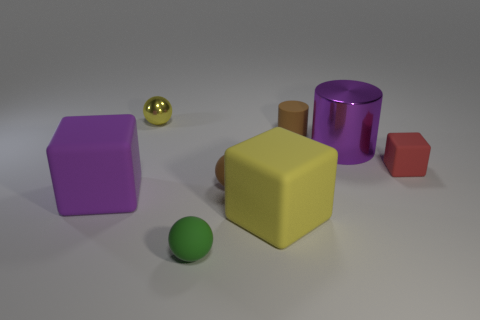What is the shape of the purple metal object that is the same size as the yellow cube?
Your answer should be very brief. Cylinder. Are there the same number of green matte spheres that are behind the yellow sphere and tiny shiny spheres right of the small red matte object?
Your response must be concise. Yes. Are there any other things that are the same shape as the red rubber thing?
Offer a terse response. Yes. Do the brown thing to the left of the tiny cylinder and the small yellow sphere have the same material?
Ensure brevity in your answer.  No. There is a yellow cube that is the same size as the purple block; what is it made of?
Your response must be concise. Rubber. How many other things are made of the same material as the small brown ball?
Offer a terse response. 5. Is the size of the brown ball the same as the sphere that is to the left of the tiny green thing?
Provide a succinct answer. Yes. Is the number of purple shiny cylinders left of the tiny brown matte ball less than the number of tiny red objects that are behind the red matte block?
Your response must be concise. No. There is a shiny thing on the right side of the big yellow cube; what is its size?
Give a very brief answer. Large. Is the size of the purple metallic thing the same as the yellow metallic sphere?
Provide a short and direct response. No. 